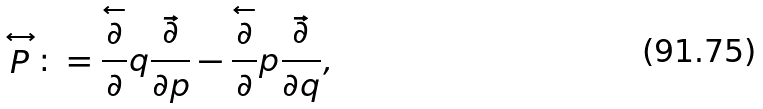<formula> <loc_0><loc_0><loc_500><loc_500>\stackrel { \leftrightarrow } { P } \colon = \frac { \stackrel { \leftarrow } { \partial } } \partial q \frac { \vec { \partial } } { \partial p } - \frac { \stackrel { \leftarrow } { \partial } } \partial p \frac { \vec { \partial } } { \partial q } ,</formula> 